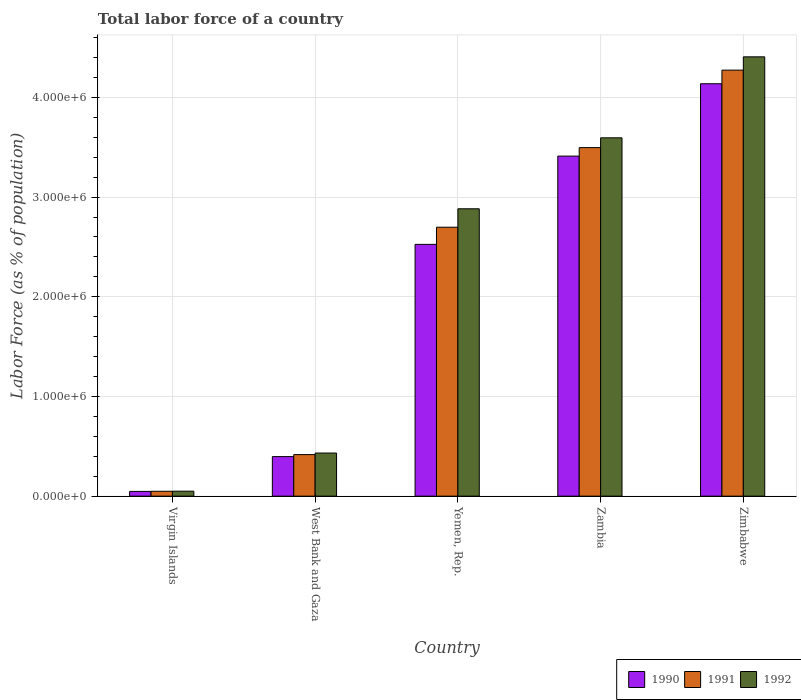How many groups of bars are there?
Ensure brevity in your answer.  5. How many bars are there on the 3rd tick from the left?
Your response must be concise. 3. How many bars are there on the 3rd tick from the right?
Make the answer very short. 3. What is the label of the 1st group of bars from the left?
Offer a very short reply. Virgin Islands. In how many cases, is the number of bars for a given country not equal to the number of legend labels?
Offer a terse response. 0. What is the percentage of labor force in 1991 in Virgin Islands?
Your answer should be compact. 4.91e+04. Across all countries, what is the maximum percentage of labor force in 1992?
Keep it short and to the point. 4.41e+06. Across all countries, what is the minimum percentage of labor force in 1990?
Keep it short and to the point. 4.78e+04. In which country was the percentage of labor force in 1990 maximum?
Ensure brevity in your answer.  Zimbabwe. In which country was the percentage of labor force in 1991 minimum?
Offer a very short reply. Virgin Islands. What is the total percentage of labor force in 1991 in the graph?
Make the answer very short. 1.09e+07. What is the difference between the percentage of labor force in 1992 in Virgin Islands and that in Yemen, Rep.?
Your answer should be very brief. -2.83e+06. What is the difference between the percentage of labor force in 1992 in Zimbabwe and the percentage of labor force in 1991 in Virgin Islands?
Give a very brief answer. 4.36e+06. What is the average percentage of labor force in 1991 per country?
Your response must be concise. 2.19e+06. What is the difference between the percentage of labor force of/in 1991 and percentage of labor force of/in 1992 in Zambia?
Make the answer very short. -9.83e+04. In how many countries, is the percentage of labor force in 1992 greater than 600000 %?
Your answer should be compact. 3. What is the ratio of the percentage of labor force in 1990 in Zambia to that in Zimbabwe?
Provide a short and direct response. 0.82. Is the percentage of labor force in 1992 in Virgin Islands less than that in Zambia?
Offer a terse response. Yes. Is the difference between the percentage of labor force in 1991 in Yemen, Rep. and Zambia greater than the difference between the percentage of labor force in 1992 in Yemen, Rep. and Zambia?
Offer a terse response. No. What is the difference between the highest and the second highest percentage of labor force in 1992?
Your answer should be compact. -7.12e+05. What is the difference between the highest and the lowest percentage of labor force in 1992?
Provide a succinct answer. 4.36e+06. In how many countries, is the percentage of labor force in 1990 greater than the average percentage of labor force in 1990 taken over all countries?
Ensure brevity in your answer.  3. Is the sum of the percentage of labor force in 1991 in West Bank and Gaza and Zambia greater than the maximum percentage of labor force in 1992 across all countries?
Provide a succinct answer. No. What does the 3rd bar from the right in Zambia represents?
Give a very brief answer. 1990. How many countries are there in the graph?
Give a very brief answer. 5. What is the difference between two consecutive major ticks on the Y-axis?
Provide a short and direct response. 1.00e+06. Are the values on the major ticks of Y-axis written in scientific E-notation?
Keep it short and to the point. Yes. Does the graph contain any zero values?
Your answer should be very brief. No. Where does the legend appear in the graph?
Keep it short and to the point. Bottom right. How many legend labels are there?
Make the answer very short. 3. How are the legend labels stacked?
Give a very brief answer. Horizontal. What is the title of the graph?
Keep it short and to the point. Total labor force of a country. Does "2005" appear as one of the legend labels in the graph?
Your response must be concise. No. What is the label or title of the Y-axis?
Provide a succinct answer. Labor Force (as % of population). What is the Labor Force (as % of population) in 1990 in Virgin Islands?
Your answer should be very brief. 4.78e+04. What is the Labor Force (as % of population) of 1991 in Virgin Islands?
Offer a terse response. 4.91e+04. What is the Labor Force (as % of population) of 1992 in Virgin Islands?
Your response must be concise. 5.00e+04. What is the Labor Force (as % of population) in 1990 in West Bank and Gaza?
Offer a terse response. 3.97e+05. What is the Labor Force (as % of population) of 1991 in West Bank and Gaza?
Provide a succinct answer. 4.17e+05. What is the Labor Force (as % of population) of 1992 in West Bank and Gaza?
Provide a short and direct response. 4.33e+05. What is the Labor Force (as % of population) in 1990 in Yemen, Rep.?
Provide a short and direct response. 2.53e+06. What is the Labor Force (as % of population) in 1991 in Yemen, Rep.?
Your response must be concise. 2.70e+06. What is the Labor Force (as % of population) of 1992 in Yemen, Rep.?
Make the answer very short. 2.88e+06. What is the Labor Force (as % of population) in 1990 in Zambia?
Give a very brief answer. 3.41e+06. What is the Labor Force (as % of population) of 1991 in Zambia?
Ensure brevity in your answer.  3.50e+06. What is the Labor Force (as % of population) of 1992 in Zambia?
Keep it short and to the point. 3.59e+06. What is the Labor Force (as % of population) of 1990 in Zimbabwe?
Offer a very short reply. 4.14e+06. What is the Labor Force (as % of population) of 1991 in Zimbabwe?
Ensure brevity in your answer.  4.27e+06. What is the Labor Force (as % of population) of 1992 in Zimbabwe?
Provide a short and direct response. 4.41e+06. Across all countries, what is the maximum Labor Force (as % of population) in 1990?
Ensure brevity in your answer.  4.14e+06. Across all countries, what is the maximum Labor Force (as % of population) of 1991?
Your answer should be very brief. 4.27e+06. Across all countries, what is the maximum Labor Force (as % of population) in 1992?
Give a very brief answer. 4.41e+06. Across all countries, what is the minimum Labor Force (as % of population) in 1990?
Your response must be concise. 4.78e+04. Across all countries, what is the minimum Labor Force (as % of population) of 1991?
Make the answer very short. 4.91e+04. Across all countries, what is the minimum Labor Force (as % of population) in 1992?
Give a very brief answer. 5.00e+04. What is the total Labor Force (as % of population) in 1990 in the graph?
Provide a short and direct response. 1.05e+07. What is the total Labor Force (as % of population) of 1991 in the graph?
Your response must be concise. 1.09e+07. What is the total Labor Force (as % of population) of 1992 in the graph?
Offer a very short reply. 1.14e+07. What is the difference between the Labor Force (as % of population) of 1990 in Virgin Islands and that in West Bank and Gaza?
Give a very brief answer. -3.49e+05. What is the difference between the Labor Force (as % of population) in 1991 in Virgin Islands and that in West Bank and Gaza?
Provide a succinct answer. -3.68e+05. What is the difference between the Labor Force (as % of population) in 1992 in Virgin Islands and that in West Bank and Gaza?
Your answer should be compact. -3.83e+05. What is the difference between the Labor Force (as % of population) in 1990 in Virgin Islands and that in Yemen, Rep.?
Provide a succinct answer. -2.48e+06. What is the difference between the Labor Force (as % of population) of 1991 in Virgin Islands and that in Yemen, Rep.?
Offer a terse response. -2.65e+06. What is the difference between the Labor Force (as % of population) in 1992 in Virgin Islands and that in Yemen, Rep.?
Your answer should be compact. -2.83e+06. What is the difference between the Labor Force (as % of population) in 1990 in Virgin Islands and that in Zambia?
Make the answer very short. -3.36e+06. What is the difference between the Labor Force (as % of population) of 1991 in Virgin Islands and that in Zambia?
Give a very brief answer. -3.45e+06. What is the difference between the Labor Force (as % of population) in 1992 in Virgin Islands and that in Zambia?
Keep it short and to the point. -3.54e+06. What is the difference between the Labor Force (as % of population) of 1990 in Virgin Islands and that in Zimbabwe?
Your answer should be compact. -4.09e+06. What is the difference between the Labor Force (as % of population) in 1991 in Virgin Islands and that in Zimbabwe?
Make the answer very short. -4.22e+06. What is the difference between the Labor Force (as % of population) in 1992 in Virgin Islands and that in Zimbabwe?
Make the answer very short. -4.36e+06. What is the difference between the Labor Force (as % of population) of 1990 in West Bank and Gaza and that in Yemen, Rep.?
Keep it short and to the point. -2.13e+06. What is the difference between the Labor Force (as % of population) of 1991 in West Bank and Gaza and that in Yemen, Rep.?
Give a very brief answer. -2.28e+06. What is the difference between the Labor Force (as % of population) of 1992 in West Bank and Gaza and that in Yemen, Rep.?
Your answer should be compact. -2.45e+06. What is the difference between the Labor Force (as % of population) in 1990 in West Bank and Gaza and that in Zambia?
Ensure brevity in your answer.  -3.01e+06. What is the difference between the Labor Force (as % of population) of 1991 in West Bank and Gaza and that in Zambia?
Provide a short and direct response. -3.08e+06. What is the difference between the Labor Force (as % of population) of 1992 in West Bank and Gaza and that in Zambia?
Offer a terse response. -3.16e+06. What is the difference between the Labor Force (as % of population) in 1990 in West Bank and Gaza and that in Zimbabwe?
Your response must be concise. -3.74e+06. What is the difference between the Labor Force (as % of population) in 1991 in West Bank and Gaza and that in Zimbabwe?
Give a very brief answer. -3.86e+06. What is the difference between the Labor Force (as % of population) in 1992 in West Bank and Gaza and that in Zimbabwe?
Offer a terse response. -3.97e+06. What is the difference between the Labor Force (as % of population) in 1990 in Yemen, Rep. and that in Zambia?
Your answer should be very brief. -8.85e+05. What is the difference between the Labor Force (as % of population) of 1991 in Yemen, Rep. and that in Zambia?
Your response must be concise. -7.98e+05. What is the difference between the Labor Force (as % of population) in 1992 in Yemen, Rep. and that in Zambia?
Give a very brief answer. -7.12e+05. What is the difference between the Labor Force (as % of population) in 1990 in Yemen, Rep. and that in Zimbabwe?
Offer a terse response. -1.61e+06. What is the difference between the Labor Force (as % of population) of 1991 in Yemen, Rep. and that in Zimbabwe?
Your answer should be compact. -1.58e+06. What is the difference between the Labor Force (as % of population) of 1992 in Yemen, Rep. and that in Zimbabwe?
Provide a succinct answer. -1.52e+06. What is the difference between the Labor Force (as % of population) of 1990 in Zambia and that in Zimbabwe?
Provide a succinct answer. -7.26e+05. What is the difference between the Labor Force (as % of population) of 1991 in Zambia and that in Zimbabwe?
Offer a terse response. -7.77e+05. What is the difference between the Labor Force (as % of population) of 1992 in Zambia and that in Zimbabwe?
Make the answer very short. -8.12e+05. What is the difference between the Labor Force (as % of population) of 1990 in Virgin Islands and the Labor Force (as % of population) of 1991 in West Bank and Gaza?
Your response must be concise. -3.69e+05. What is the difference between the Labor Force (as % of population) of 1990 in Virgin Islands and the Labor Force (as % of population) of 1992 in West Bank and Gaza?
Keep it short and to the point. -3.85e+05. What is the difference between the Labor Force (as % of population) of 1991 in Virgin Islands and the Labor Force (as % of population) of 1992 in West Bank and Gaza?
Provide a short and direct response. -3.83e+05. What is the difference between the Labor Force (as % of population) of 1990 in Virgin Islands and the Labor Force (as % of population) of 1991 in Yemen, Rep.?
Offer a very short reply. -2.65e+06. What is the difference between the Labor Force (as % of population) of 1990 in Virgin Islands and the Labor Force (as % of population) of 1992 in Yemen, Rep.?
Give a very brief answer. -2.83e+06. What is the difference between the Labor Force (as % of population) in 1991 in Virgin Islands and the Labor Force (as % of population) in 1992 in Yemen, Rep.?
Your response must be concise. -2.83e+06. What is the difference between the Labor Force (as % of population) in 1990 in Virgin Islands and the Labor Force (as % of population) in 1991 in Zambia?
Offer a very short reply. -3.45e+06. What is the difference between the Labor Force (as % of population) in 1990 in Virgin Islands and the Labor Force (as % of population) in 1992 in Zambia?
Keep it short and to the point. -3.55e+06. What is the difference between the Labor Force (as % of population) of 1991 in Virgin Islands and the Labor Force (as % of population) of 1992 in Zambia?
Give a very brief answer. -3.55e+06. What is the difference between the Labor Force (as % of population) of 1990 in Virgin Islands and the Labor Force (as % of population) of 1991 in Zimbabwe?
Your response must be concise. -4.23e+06. What is the difference between the Labor Force (as % of population) of 1990 in Virgin Islands and the Labor Force (as % of population) of 1992 in Zimbabwe?
Make the answer very short. -4.36e+06. What is the difference between the Labor Force (as % of population) in 1991 in Virgin Islands and the Labor Force (as % of population) in 1992 in Zimbabwe?
Your answer should be compact. -4.36e+06. What is the difference between the Labor Force (as % of population) in 1990 in West Bank and Gaza and the Labor Force (as % of population) in 1991 in Yemen, Rep.?
Give a very brief answer. -2.30e+06. What is the difference between the Labor Force (as % of population) of 1990 in West Bank and Gaza and the Labor Force (as % of population) of 1992 in Yemen, Rep.?
Offer a terse response. -2.49e+06. What is the difference between the Labor Force (as % of population) in 1991 in West Bank and Gaza and the Labor Force (as % of population) in 1992 in Yemen, Rep.?
Offer a terse response. -2.47e+06. What is the difference between the Labor Force (as % of population) of 1990 in West Bank and Gaza and the Labor Force (as % of population) of 1991 in Zambia?
Provide a short and direct response. -3.10e+06. What is the difference between the Labor Force (as % of population) of 1990 in West Bank and Gaza and the Labor Force (as % of population) of 1992 in Zambia?
Provide a short and direct response. -3.20e+06. What is the difference between the Labor Force (as % of population) of 1991 in West Bank and Gaza and the Labor Force (as % of population) of 1992 in Zambia?
Offer a terse response. -3.18e+06. What is the difference between the Labor Force (as % of population) in 1990 in West Bank and Gaza and the Labor Force (as % of population) in 1991 in Zimbabwe?
Your answer should be very brief. -3.88e+06. What is the difference between the Labor Force (as % of population) of 1990 in West Bank and Gaza and the Labor Force (as % of population) of 1992 in Zimbabwe?
Offer a terse response. -4.01e+06. What is the difference between the Labor Force (as % of population) of 1991 in West Bank and Gaza and the Labor Force (as % of population) of 1992 in Zimbabwe?
Make the answer very short. -3.99e+06. What is the difference between the Labor Force (as % of population) of 1990 in Yemen, Rep. and the Labor Force (as % of population) of 1991 in Zambia?
Keep it short and to the point. -9.70e+05. What is the difference between the Labor Force (as % of population) in 1990 in Yemen, Rep. and the Labor Force (as % of population) in 1992 in Zambia?
Provide a succinct answer. -1.07e+06. What is the difference between the Labor Force (as % of population) of 1991 in Yemen, Rep. and the Labor Force (as % of population) of 1992 in Zambia?
Make the answer very short. -8.97e+05. What is the difference between the Labor Force (as % of population) of 1990 in Yemen, Rep. and the Labor Force (as % of population) of 1991 in Zimbabwe?
Your response must be concise. -1.75e+06. What is the difference between the Labor Force (as % of population) of 1990 in Yemen, Rep. and the Labor Force (as % of population) of 1992 in Zimbabwe?
Provide a succinct answer. -1.88e+06. What is the difference between the Labor Force (as % of population) in 1991 in Yemen, Rep. and the Labor Force (as % of population) in 1992 in Zimbabwe?
Offer a very short reply. -1.71e+06. What is the difference between the Labor Force (as % of population) in 1990 in Zambia and the Labor Force (as % of population) in 1991 in Zimbabwe?
Your answer should be compact. -8.62e+05. What is the difference between the Labor Force (as % of population) of 1990 in Zambia and the Labor Force (as % of population) of 1992 in Zimbabwe?
Make the answer very short. -9.96e+05. What is the difference between the Labor Force (as % of population) of 1991 in Zambia and the Labor Force (as % of population) of 1992 in Zimbabwe?
Ensure brevity in your answer.  -9.10e+05. What is the average Labor Force (as % of population) in 1990 per country?
Ensure brevity in your answer.  2.10e+06. What is the average Labor Force (as % of population) of 1991 per country?
Provide a short and direct response. 2.19e+06. What is the average Labor Force (as % of population) of 1992 per country?
Your response must be concise. 2.27e+06. What is the difference between the Labor Force (as % of population) of 1990 and Labor Force (as % of population) of 1991 in Virgin Islands?
Offer a terse response. -1288. What is the difference between the Labor Force (as % of population) in 1990 and Labor Force (as % of population) in 1992 in Virgin Islands?
Offer a very short reply. -2120. What is the difference between the Labor Force (as % of population) in 1991 and Labor Force (as % of population) in 1992 in Virgin Islands?
Ensure brevity in your answer.  -832. What is the difference between the Labor Force (as % of population) of 1990 and Labor Force (as % of population) of 1991 in West Bank and Gaza?
Ensure brevity in your answer.  -2.01e+04. What is the difference between the Labor Force (as % of population) in 1990 and Labor Force (as % of population) in 1992 in West Bank and Gaza?
Your answer should be very brief. -3.56e+04. What is the difference between the Labor Force (as % of population) of 1991 and Labor Force (as % of population) of 1992 in West Bank and Gaza?
Make the answer very short. -1.56e+04. What is the difference between the Labor Force (as % of population) in 1990 and Labor Force (as % of population) in 1991 in Yemen, Rep.?
Your answer should be compact. -1.72e+05. What is the difference between the Labor Force (as % of population) in 1990 and Labor Force (as % of population) in 1992 in Yemen, Rep.?
Keep it short and to the point. -3.57e+05. What is the difference between the Labor Force (as % of population) of 1991 and Labor Force (as % of population) of 1992 in Yemen, Rep.?
Ensure brevity in your answer.  -1.85e+05. What is the difference between the Labor Force (as % of population) in 1990 and Labor Force (as % of population) in 1991 in Zambia?
Provide a succinct answer. -8.52e+04. What is the difference between the Labor Force (as % of population) of 1990 and Labor Force (as % of population) of 1992 in Zambia?
Provide a succinct answer. -1.83e+05. What is the difference between the Labor Force (as % of population) of 1991 and Labor Force (as % of population) of 1992 in Zambia?
Provide a succinct answer. -9.83e+04. What is the difference between the Labor Force (as % of population) in 1990 and Labor Force (as % of population) in 1991 in Zimbabwe?
Provide a succinct answer. -1.36e+05. What is the difference between the Labor Force (as % of population) in 1990 and Labor Force (as % of population) in 1992 in Zimbabwe?
Provide a short and direct response. -2.70e+05. What is the difference between the Labor Force (as % of population) of 1991 and Labor Force (as % of population) of 1992 in Zimbabwe?
Keep it short and to the point. -1.33e+05. What is the ratio of the Labor Force (as % of population) in 1990 in Virgin Islands to that in West Bank and Gaza?
Your answer should be compact. 0.12. What is the ratio of the Labor Force (as % of population) of 1991 in Virgin Islands to that in West Bank and Gaza?
Keep it short and to the point. 0.12. What is the ratio of the Labor Force (as % of population) of 1992 in Virgin Islands to that in West Bank and Gaza?
Your answer should be very brief. 0.12. What is the ratio of the Labor Force (as % of population) in 1990 in Virgin Islands to that in Yemen, Rep.?
Give a very brief answer. 0.02. What is the ratio of the Labor Force (as % of population) in 1991 in Virgin Islands to that in Yemen, Rep.?
Your answer should be compact. 0.02. What is the ratio of the Labor Force (as % of population) in 1992 in Virgin Islands to that in Yemen, Rep.?
Your response must be concise. 0.02. What is the ratio of the Labor Force (as % of population) in 1990 in Virgin Islands to that in Zambia?
Provide a succinct answer. 0.01. What is the ratio of the Labor Force (as % of population) of 1991 in Virgin Islands to that in Zambia?
Give a very brief answer. 0.01. What is the ratio of the Labor Force (as % of population) in 1992 in Virgin Islands to that in Zambia?
Make the answer very short. 0.01. What is the ratio of the Labor Force (as % of population) in 1990 in Virgin Islands to that in Zimbabwe?
Make the answer very short. 0.01. What is the ratio of the Labor Force (as % of population) in 1991 in Virgin Islands to that in Zimbabwe?
Give a very brief answer. 0.01. What is the ratio of the Labor Force (as % of population) in 1992 in Virgin Islands to that in Zimbabwe?
Provide a succinct answer. 0.01. What is the ratio of the Labor Force (as % of population) of 1990 in West Bank and Gaza to that in Yemen, Rep.?
Your response must be concise. 0.16. What is the ratio of the Labor Force (as % of population) in 1991 in West Bank and Gaza to that in Yemen, Rep.?
Offer a very short reply. 0.15. What is the ratio of the Labor Force (as % of population) in 1992 in West Bank and Gaza to that in Yemen, Rep.?
Provide a short and direct response. 0.15. What is the ratio of the Labor Force (as % of population) of 1990 in West Bank and Gaza to that in Zambia?
Keep it short and to the point. 0.12. What is the ratio of the Labor Force (as % of population) of 1991 in West Bank and Gaza to that in Zambia?
Your answer should be very brief. 0.12. What is the ratio of the Labor Force (as % of population) of 1992 in West Bank and Gaza to that in Zambia?
Offer a very short reply. 0.12. What is the ratio of the Labor Force (as % of population) in 1990 in West Bank and Gaza to that in Zimbabwe?
Your response must be concise. 0.1. What is the ratio of the Labor Force (as % of population) in 1991 in West Bank and Gaza to that in Zimbabwe?
Keep it short and to the point. 0.1. What is the ratio of the Labor Force (as % of population) of 1992 in West Bank and Gaza to that in Zimbabwe?
Make the answer very short. 0.1. What is the ratio of the Labor Force (as % of population) of 1990 in Yemen, Rep. to that in Zambia?
Your response must be concise. 0.74. What is the ratio of the Labor Force (as % of population) in 1991 in Yemen, Rep. to that in Zambia?
Provide a short and direct response. 0.77. What is the ratio of the Labor Force (as % of population) of 1992 in Yemen, Rep. to that in Zambia?
Offer a very short reply. 0.8. What is the ratio of the Labor Force (as % of population) of 1990 in Yemen, Rep. to that in Zimbabwe?
Provide a succinct answer. 0.61. What is the ratio of the Labor Force (as % of population) in 1991 in Yemen, Rep. to that in Zimbabwe?
Make the answer very short. 0.63. What is the ratio of the Labor Force (as % of population) of 1992 in Yemen, Rep. to that in Zimbabwe?
Give a very brief answer. 0.65. What is the ratio of the Labor Force (as % of population) of 1990 in Zambia to that in Zimbabwe?
Make the answer very short. 0.82. What is the ratio of the Labor Force (as % of population) in 1991 in Zambia to that in Zimbabwe?
Your response must be concise. 0.82. What is the ratio of the Labor Force (as % of population) of 1992 in Zambia to that in Zimbabwe?
Make the answer very short. 0.82. What is the difference between the highest and the second highest Labor Force (as % of population) of 1990?
Provide a short and direct response. 7.26e+05. What is the difference between the highest and the second highest Labor Force (as % of population) in 1991?
Provide a succinct answer. 7.77e+05. What is the difference between the highest and the second highest Labor Force (as % of population) in 1992?
Your answer should be very brief. 8.12e+05. What is the difference between the highest and the lowest Labor Force (as % of population) in 1990?
Provide a succinct answer. 4.09e+06. What is the difference between the highest and the lowest Labor Force (as % of population) in 1991?
Make the answer very short. 4.22e+06. What is the difference between the highest and the lowest Labor Force (as % of population) of 1992?
Provide a short and direct response. 4.36e+06. 